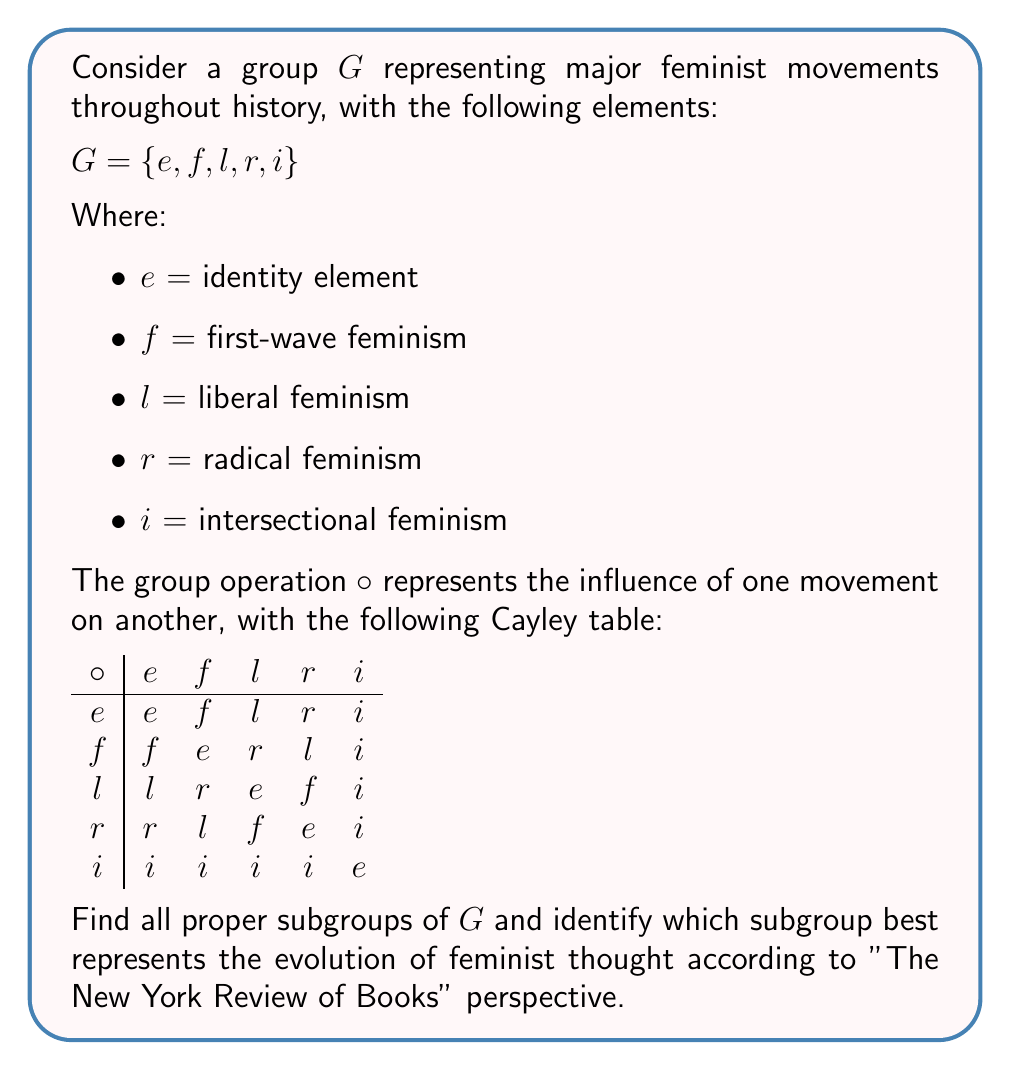Solve this math problem. To find all proper subgroups of $G$, we need to identify sets of elements that are closed under the group operation and contain the identity element. Let's proceed step-by-step:

1) First, note that every subgroup must contain the identity element $e$.

2) Check single-element subgroups:
   $\{e\}$ is always a subgroup.
   $\{i\}$ is a subgroup as $i \circ i = e$.

3) Check two-element subgroups:
   $\{e, f\}$, $\{e, l\}$, and $\{e, r\}$ are subgroups as $f \circ f = e$, $l \circ l = e$, and $r \circ r = e$.

4) Check three-element subgroups:
   $\{e, f, l\}$, $\{e, f, r\}$, and $\{e, l, r\}$ are not subgroups as they're not closed.

5) Check four-element subgroups:
   $\{e, f, l, r\}$ is a subgroup as it's closed under the operation.

Therefore, the proper subgroups of $G$ are:
$\{e\}$, $\{i\}$, $\{e, f\}$, $\{e, l\}$, $\{e, r\}$, and $\{e, f, l, r\}$.

From "The New York Review of Books" perspective, which often emphasizes the historical progression and interconnectedness of ideas, the subgroup $\{e, f, l, r\}$ best represents the evolution of feminist thought. This subgroup includes the identity (representing the starting point), first-wave feminism, and its developments into liberal and radical feminism, showing the historical progression and interplay between these movements.
Answer: Proper subgroups: $\{e\}$, $\{i\}$, $\{e, f\}$, $\{e, l\}$, $\{e, r\}$, $\{e, f, l, r\}$. Best representing evolution: $\{e, f, l, r\}$. 